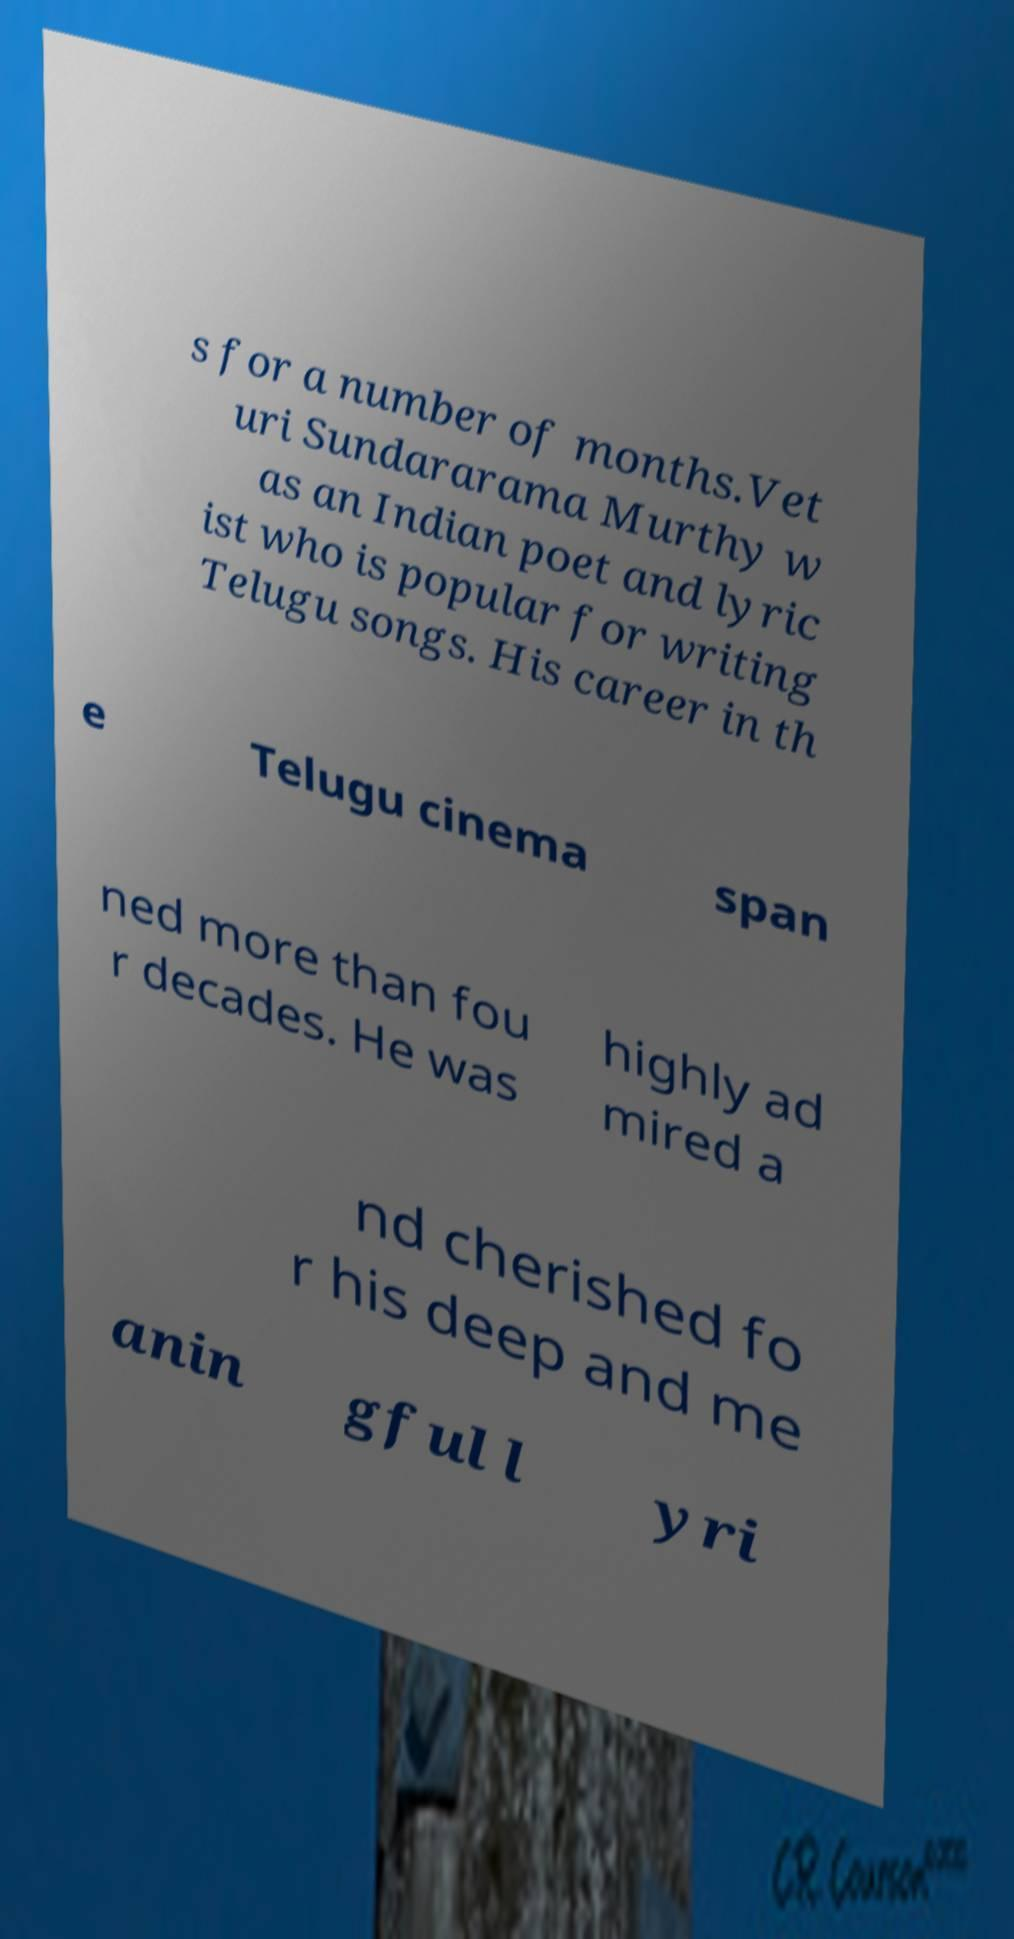Can you read and provide the text displayed in the image?This photo seems to have some interesting text. Can you extract and type it out for me? s for a number of months.Vet uri Sundararama Murthy w as an Indian poet and lyric ist who is popular for writing Telugu songs. His career in th e Telugu cinema span ned more than fou r decades. He was highly ad mired a nd cherished fo r his deep and me anin gful l yri 